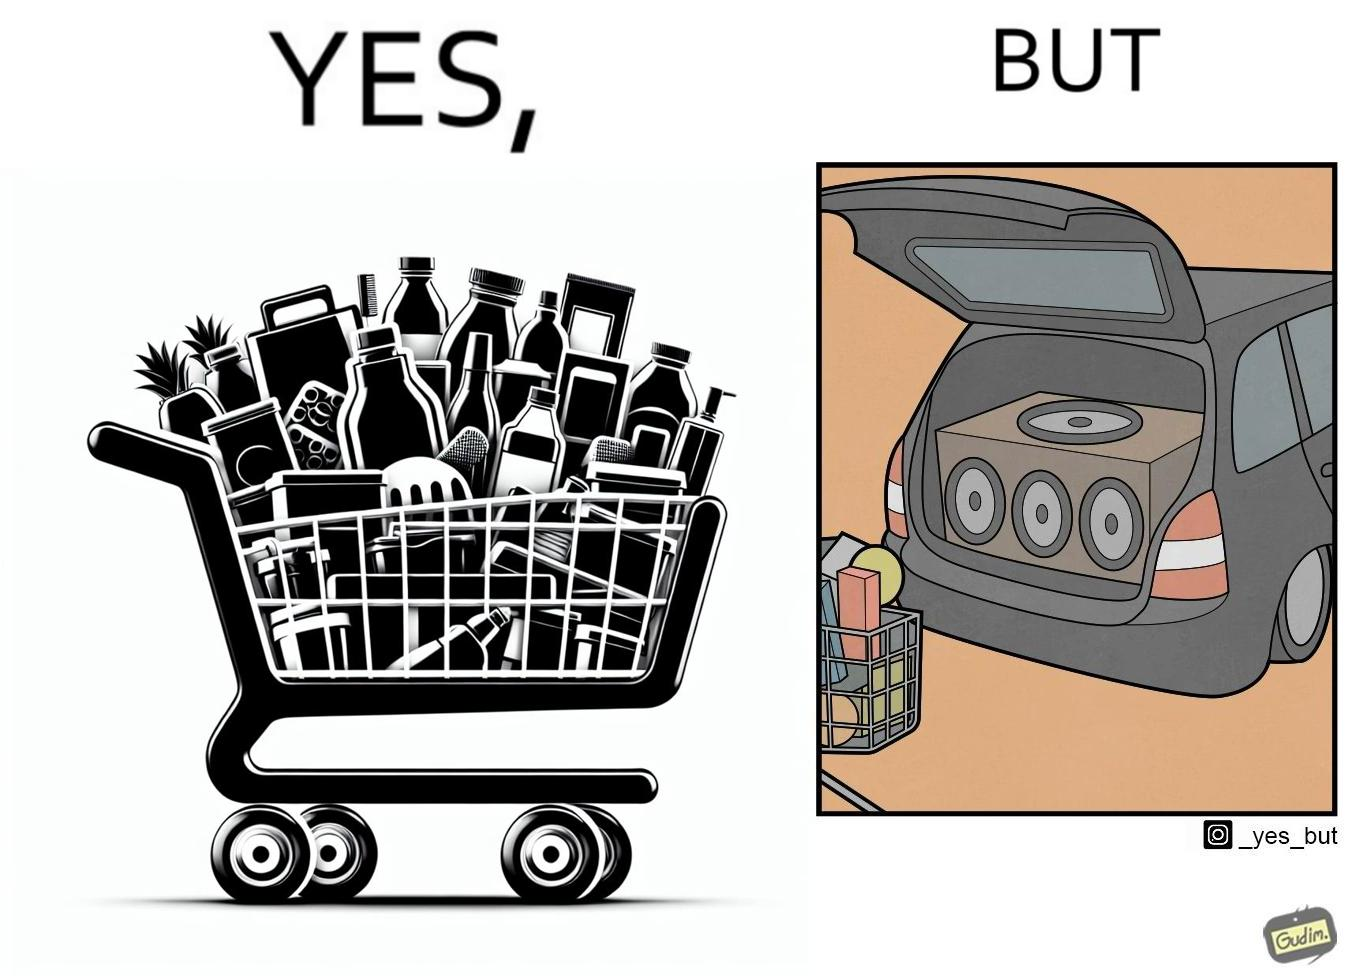What is shown in the left half versus the right half of this image? In the left part of the image: a shopping cart full of items In the right part of the image: a black car with its trunk lid open and some boxes, probably speakers, kept in the trunk 